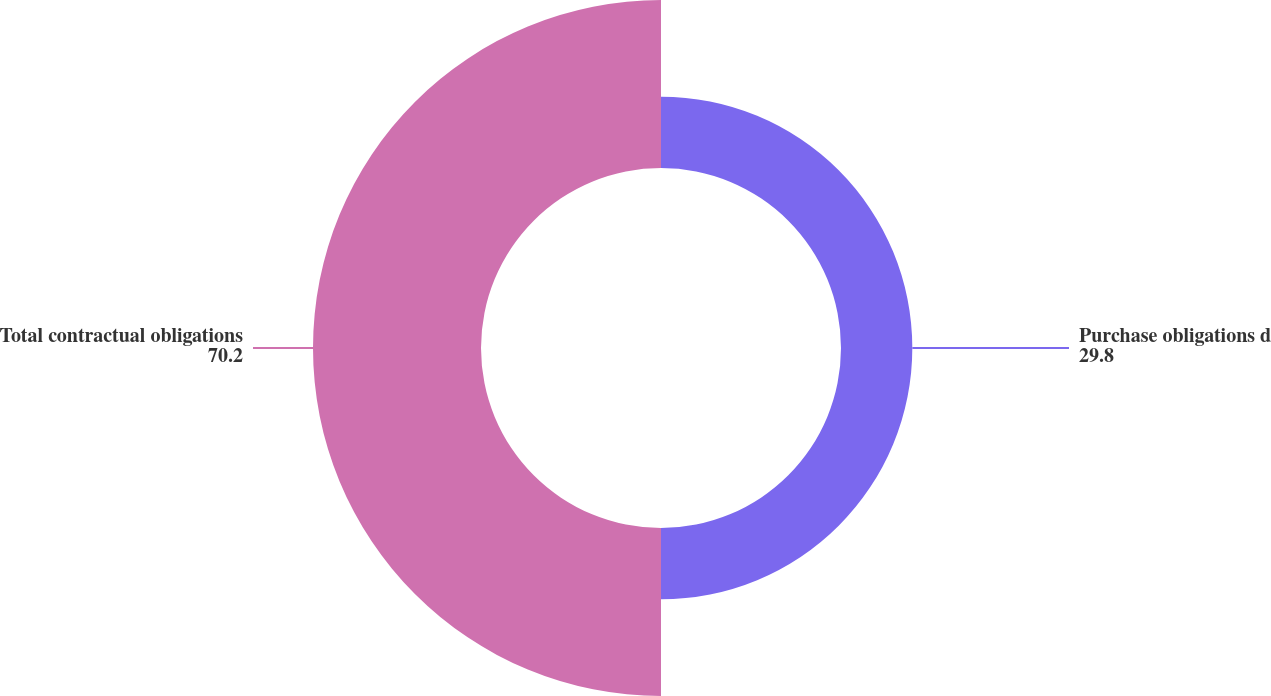Convert chart to OTSL. <chart><loc_0><loc_0><loc_500><loc_500><pie_chart><fcel>Purchase obligations d<fcel>Total contractual obligations<nl><fcel>29.8%<fcel>70.2%<nl></chart> 